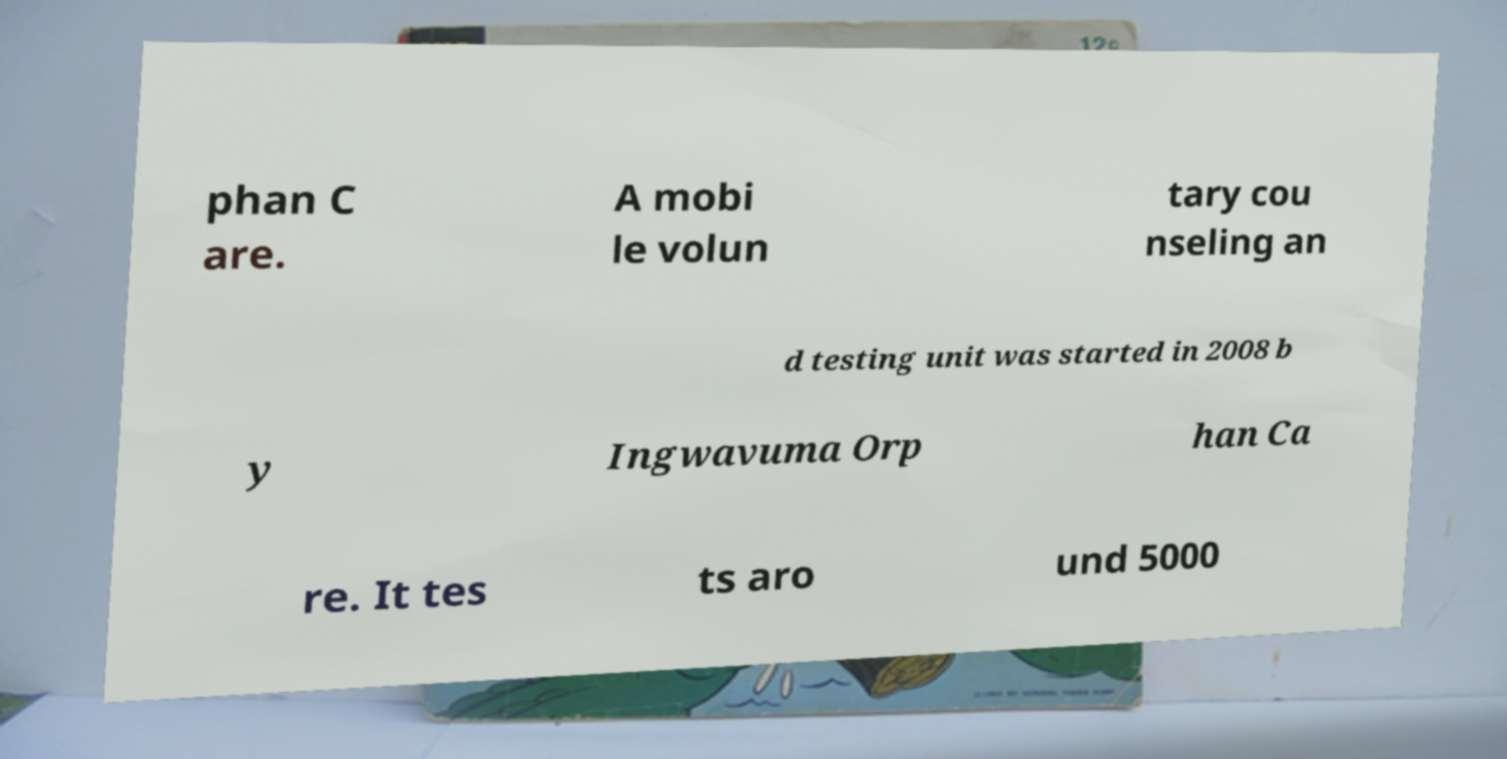Can you accurately transcribe the text from the provided image for me? phan C are. A mobi le volun tary cou nseling an d testing unit was started in 2008 b y Ingwavuma Orp han Ca re. It tes ts aro und 5000 